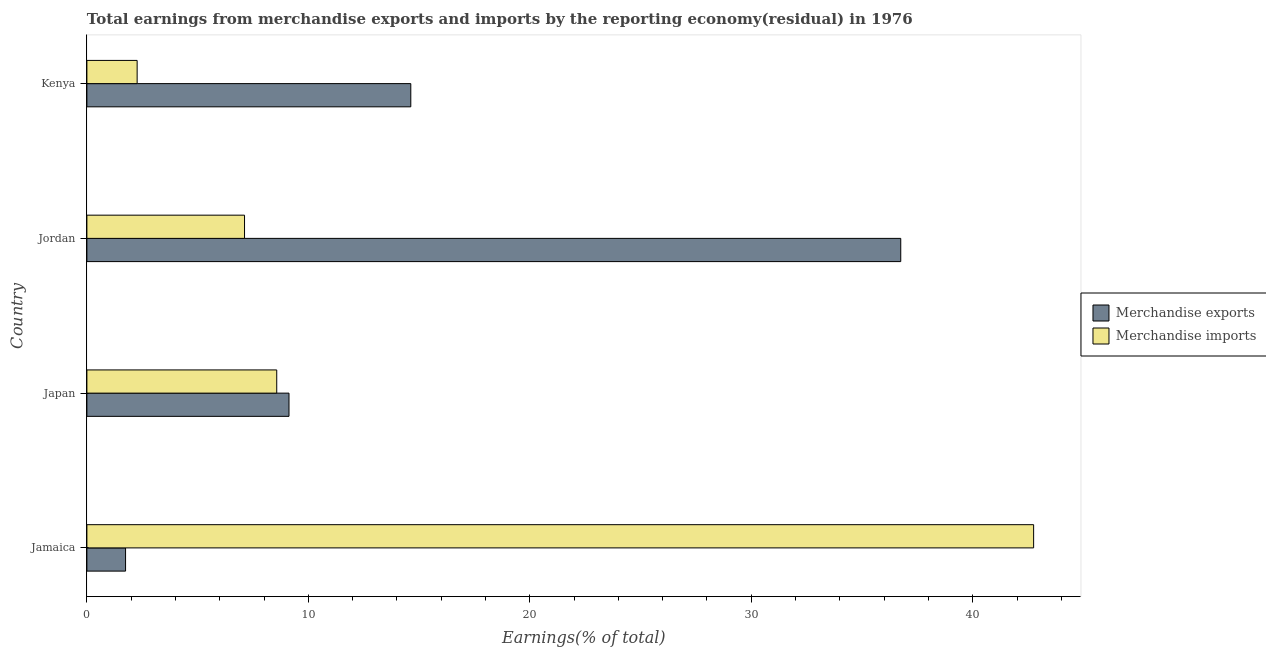How many different coloured bars are there?
Your response must be concise. 2. How many groups of bars are there?
Ensure brevity in your answer.  4. Are the number of bars per tick equal to the number of legend labels?
Keep it short and to the point. Yes. How many bars are there on the 3rd tick from the top?
Your answer should be very brief. 2. How many bars are there on the 1st tick from the bottom?
Give a very brief answer. 2. What is the label of the 3rd group of bars from the top?
Your answer should be very brief. Japan. What is the earnings from merchandise imports in Japan?
Provide a succinct answer. 8.57. Across all countries, what is the maximum earnings from merchandise exports?
Keep it short and to the point. 36.75. Across all countries, what is the minimum earnings from merchandise exports?
Your answer should be very brief. 1.75. In which country was the earnings from merchandise imports maximum?
Provide a short and direct response. Jamaica. In which country was the earnings from merchandise exports minimum?
Keep it short and to the point. Jamaica. What is the total earnings from merchandise exports in the graph?
Your answer should be compact. 62.25. What is the difference between the earnings from merchandise exports in Jamaica and that in Jordan?
Give a very brief answer. -35. What is the difference between the earnings from merchandise exports in Kenya and the earnings from merchandise imports in Jordan?
Keep it short and to the point. 7.51. What is the average earnings from merchandise exports per country?
Your response must be concise. 15.56. What is the difference between the earnings from merchandise imports and earnings from merchandise exports in Jordan?
Provide a short and direct response. -29.63. In how many countries, is the earnings from merchandise imports greater than 2 %?
Give a very brief answer. 4. What is the ratio of the earnings from merchandise imports in Jamaica to that in Kenya?
Your answer should be compact. 18.84. What is the difference between the highest and the second highest earnings from merchandise exports?
Make the answer very short. 22.12. What does the 2nd bar from the top in Jamaica represents?
Ensure brevity in your answer.  Merchandise exports. What is the difference between two consecutive major ticks on the X-axis?
Give a very brief answer. 10. Are the values on the major ticks of X-axis written in scientific E-notation?
Ensure brevity in your answer.  No. How many legend labels are there?
Ensure brevity in your answer.  2. What is the title of the graph?
Ensure brevity in your answer.  Total earnings from merchandise exports and imports by the reporting economy(residual) in 1976. Does "Researchers" appear as one of the legend labels in the graph?
Keep it short and to the point. No. What is the label or title of the X-axis?
Ensure brevity in your answer.  Earnings(% of total). What is the Earnings(% of total) in Merchandise exports in Jamaica?
Your answer should be compact. 1.75. What is the Earnings(% of total) of Merchandise imports in Jamaica?
Your answer should be compact. 42.75. What is the Earnings(% of total) in Merchandise exports in Japan?
Ensure brevity in your answer.  9.13. What is the Earnings(% of total) of Merchandise imports in Japan?
Offer a terse response. 8.57. What is the Earnings(% of total) of Merchandise exports in Jordan?
Give a very brief answer. 36.75. What is the Earnings(% of total) in Merchandise imports in Jordan?
Keep it short and to the point. 7.12. What is the Earnings(% of total) of Merchandise exports in Kenya?
Your response must be concise. 14.63. What is the Earnings(% of total) of Merchandise imports in Kenya?
Provide a succinct answer. 2.27. Across all countries, what is the maximum Earnings(% of total) in Merchandise exports?
Give a very brief answer. 36.75. Across all countries, what is the maximum Earnings(% of total) of Merchandise imports?
Your answer should be compact. 42.75. Across all countries, what is the minimum Earnings(% of total) of Merchandise exports?
Ensure brevity in your answer.  1.75. Across all countries, what is the minimum Earnings(% of total) of Merchandise imports?
Offer a very short reply. 2.27. What is the total Earnings(% of total) in Merchandise exports in the graph?
Your answer should be compact. 62.25. What is the total Earnings(% of total) of Merchandise imports in the graph?
Your answer should be very brief. 60.71. What is the difference between the Earnings(% of total) in Merchandise exports in Jamaica and that in Japan?
Give a very brief answer. -7.38. What is the difference between the Earnings(% of total) of Merchandise imports in Jamaica and that in Japan?
Provide a short and direct response. 34.18. What is the difference between the Earnings(% of total) in Merchandise exports in Jamaica and that in Jordan?
Provide a succinct answer. -35. What is the difference between the Earnings(% of total) in Merchandise imports in Jamaica and that in Jordan?
Offer a very short reply. 35.63. What is the difference between the Earnings(% of total) in Merchandise exports in Jamaica and that in Kenya?
Provide a short and direct response. -12.88. What is the difference between the Earnings(% of total) in Merchandise imports in Jamaica and that in Kenya?
Your response must be concise. 40.48. What is the difference between the Earnings(% of total) of Merchandise exports in Japan and that in Jordan?
Offer a terse response. -27.62. What is the difference between the Earnings(% of total) in Merchandise imports in Japan and that in Jordan?
Ensure brevity in your answer.  1.45. What is the difference between the Earnings(% of total) of Merchandise exports in Japan and that in Kenya?
Give a very brief answer. -5.5. What is the difference between the Earnings(% of total) in Merchandise imports in Japan and that in Kenya?
Offer a very short reply. 6.3. What is the difference between the Earnings(% of total) in Merchandise exports in Jordan and that in Kenya?
Provide a short and direct response. 22.12. What is the difference between the Earnings(% of total) in Merchandise imports in Jordan and that in Kenya?
Your response must be concise. 4.85. What is the difference between the Earnings(% of total) in Merchandise exports in Jamaica and the Earnings(% of total) in Merchandise imports in Japan?
Provide a short and direct response. -6.83. What is the difference between the Earnings(% of total) in Merchandise exports in Jamaica and the Earnings(% of total) in Merchandise imports in Jordan?
Make the answer very short. -5.37. What is the difference between the Earnings(% of total) in Merchandise exports in Jamaica and the Earnings(% of total) in Merchandise imports in Kenya?
Your answer should be compact. -0.52. What is the difference between the Earnings(% of total) in Merchandise exports in Japan and the Earnings(% of total) in Merchandise imports in Jordan?
Offer a terse response. 2.01. What is the difference between the Earnings(% of total) of Merchandise exports in Japan and the Earnings(% of total) of Merchandise imports in Kenya?
Your response must be concise. 6.86. What is the difference between the Earnings(% of total) of Merchandise exports in Jordan and the Earnings(% of total) of Merchandise imports in Kenya?
Your answer should be very brief. 34.48. What is the average Earnings(% of total) in Merchandise exports per country?
Keep it short and to the point. 15.56. What is the average Earnings(% of total) of Merchandise imports per country?
Offer a terse response. 15.18. What is the difference between the Earnings(% of total) of Merchandise exports and Earnings(% of total) of Merchandise imports in Jamaica?
Your answer should be very brief. -41. What is the difference between the Earnings(% of total) in Merchandise exports and Earnings(% of total) in Merchandise imports in Japan?
Make the answer very short. 0.55. What is the difference between the Earnings(% of total) of Merchandise exports and Earnings(% of total) of Merchandise imports in Jordan?
Your response must be concise. 29.63. What is the difference between the Earnings(% of total) in Merchandise exports and Earnings(% of total) in Merchandise imports in Kenya?
Your answer should be very brief. 12.36. What is the ratio of the Earnings(% of total) in Merchandise exports in Jamaica to that in Japan?
Provide a succinct answer. 0.19. What is the ratio of the Earnings(% of total) of Merchandise imports in Jamaica to that in Japan?
Keep it short and to the point. 4.99. What is the ratio of the Earnings(% of total) in Merchandise exports in Jamaica to that in Jordan?
Ensure brevity in your answer.  0.05. What is the ratio of the Earnings(% of total) in Merchandise imports in Jamaica to that in Jordan?
Provide a succinct answer. 6.01. What is the ratio of the Earnings(% of total) of Merchandise exports in Jamaica to that in Kenya?
Make the answer very short. 0.12. What is the ratio of the Earnings(% of total) of Merchandise imports in Jamaica to that in Kenya?
Provide a succinct answer. 18.84. What is the ratio of the Earnings(% of total) in Merchandise exports in Japan to that in Jordan?
Offer a terse response. 0.25. What is the ratio of the Earnings(% of total) in Merchandise imports in Japan to that in Jordan?
Provide a succinct answer. 1.2. What is the ratio of the Earnings(% of total) of Merchandise exports in Japan to that in Kenya?
Give a very brief answer. 0.62. What is the ratio of the Earnings(% of total) in Merchandise imports in Japan to that in Kenya?
Your response must be concise. 3.78. What is the ratio of the Earnings(% of total) in Merchandise exports in Jordan to that in Kenya?
Provide a short and direct response. 2.51. What is the ratio of the Earnings(% of total) in Merchandise imports in Jordan to that in Kenya?
Provide a succinct answer. 3.14. What is the difference between the highest and the second highest Earnings(% of total) of Merchandise exports?
Your response must be concise. 22.12. What is the difference between the highest and the second highest Earnings(% of total) in Merchandise imports?
Keep it short and to the point. 34.18. What is the difference between the highest and the lowest Earnings(% of total) of Merchandise exports?
Give a very brief answer. 35. What is the difference between the highest and the lowest Earnings(% of total) of Merchandise imports?
Give a very brief answer. 40.48. 